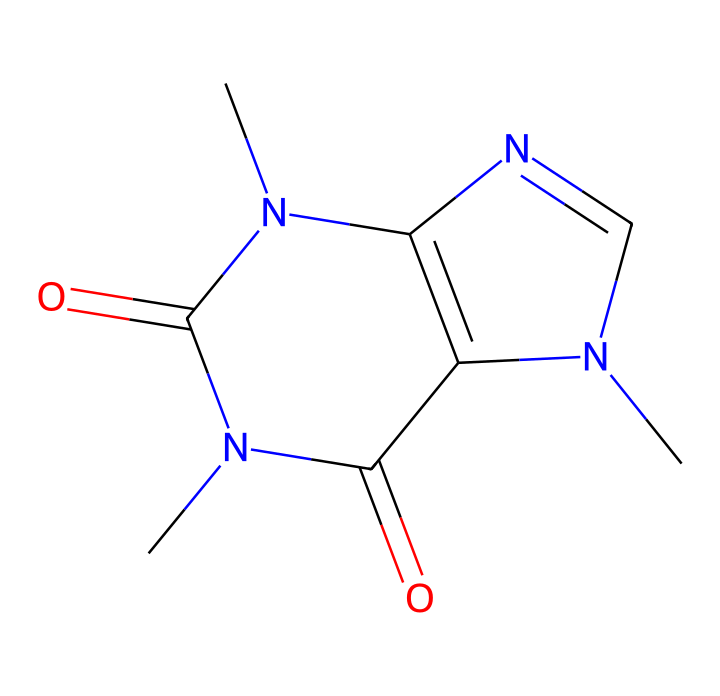What is the molecular formula of caffeine? By analyzing the SMILES representation, we can break down the atoms represented: there are 8 carbon (C), 10 hydrogen (H), and 4 nitrogen (N) atoms, and 2 oxygen (O) atoms. Thus, the molecular formula is derived as C8H10N4O2.
Answer: C8H10N4O2 How many nitrogen atoms are present in the structure? Looking at the SMILES string, we can count the occurrences of nitrogen (N), which appear four times in the representation.
Answer: 4 What type of chemical compound is caffeine? Caffeine belongs to the class of compounds known as xanthines, which are derivatives of purine. The presence of nitrogen atoms arranged in a specific configuration signifies it fits this classification.
Answer: xanthine What is the primary effect of caffeine on human alertness? Caffeine primarily acts as a stimulant, increasing alertness and reducing the perception of fatigue by blocking adenosine receptors in the brain.
Answer: stimulant Which functional groups are present in the caffeine structure? By examining the structure, we spot amine groups (due to nitrogen atoms) and carbonyl groups (due to carbon double bonded to oxygen), which can be identified through their visual presence.
Answer: amine and carbonyl How many rings are present in the structure of caffeine? Upon analyzing the structure, we note that there are two rings formed by the cyclic arrangement of carbon and nitrogen atoms, signifying a bicyclic compound.
Answer: 2 What is the role of nitrogen atoms in caffeine's effect on the central nervous system? Nitrogen atoms in caffeine play a crucial role as they contribute to the overall structure that allows caffeine to mimic adenosine, thereby affecting neurotransmitter release and signaling in the central nervous system.
Answer: mimic adenosine 